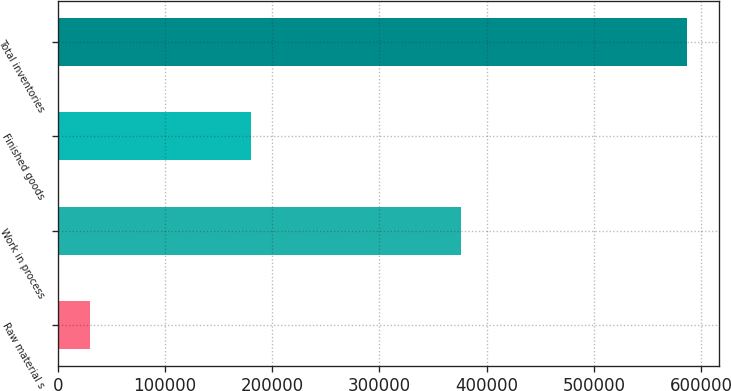<chart> <loc_0><loc_0><loc_500><loc_500><bar_chart><fcel>Raw material s<fcel>Work in process<fcel>Finished goods<fcel>Total inventories<nl><fcel>30511<fcel>375908<fcel>180341<fcel>586760<nl></chart> 